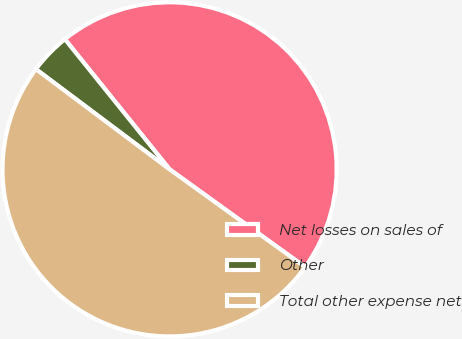<chart> <loc_0><loc_0><loc_500><loc_500><pie_chart><fcel>Net losses on sales of<fcel>Other<fcel>Total other expense net<nl><fcel>45.72%<fcel>3.98%<fcel>50.29%<nl></chart> 